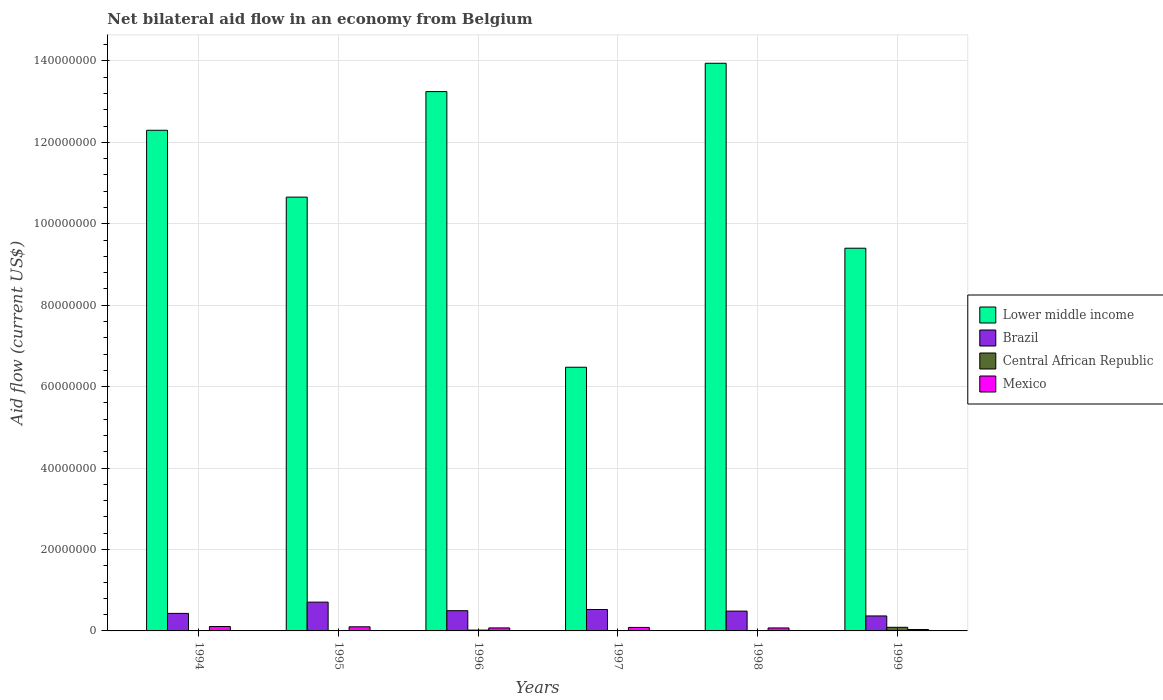How many different coloured bars are there?
Make the answer very short. 4. Are the number of bars on each tick of the X-axis equal?
Your answer should be very brief. Yes. How many bars are there on the 4th tick from the left?
Keep it short and to the point. 4. What is the net bilateral aid flow in Central African Republic in 1994?
Your response must be concise. 3.00e+04. Across all years, what is the maximum net bilateral aid flow in Mexico?
Ensure brevity in your answer.  1.08e+06. Across all years, what is the minimum net bilateral aid flow in Lower middle income?
Your answer should be compact. 6.48e+07. In which year was the net bilateral aid flow in Brazil minimum?
Offer a very short reply. 1999. What is the total net bilateral aid flow in Brazil in the graph?
Keep it short and to the point. 3.02e+07. What is the difference between the net bilateral aid flow in Lower middle income in 1994 and that in 1999?
Offer a terse response. 2.90e+07. What is the difference between the net bilateral aid flow in Central African Republic in 1998 and the net bilateral aid flow in Lower middle income in 1996?
Your answer should be very brief. -1.32e+08. What is the average net bilateral aid flow in Mexico per year?
Give a very brief answer. 7.95e+05. In the year 1996, what is the difference between the net bilateral aid flow in Brazil and net bilateral aid flow in Lower middle income?
Offer a very short reply. -1.28e+08. What is the ratio of the net bilateral aid flow in Lower middle income in 1994 to that in 1996?
Your answer should be very brief. 0.93. Is the difference between the net bilateral aid flow in Brazil in 1996 and 1999 greater than the difference between the net bilateral aid flow in Lower middle income in 1996 and 1999?
Provide a short and direct response. No. What is the difference between the highest and the second highest net bilateral aid flow in Central African Republic?
Your answer should be compact. 6.90e+05. What is the difference between the highest and the lowest net bilateral aid flow in Brazil?
Ensure brevity in your answer.  3.39e+06. Is the sum of the net bilateral aid flow in Mexico in 1995 and 1998 greater than the maximum net bilateral aid flow in Central African Republic across all years?
Keep it short and to the point. Yes. What does the 3rd bar from the left in 1998 represents?
Give a very brief answer. Central African Republic. What does the 1st bar from the right in 1996 represents?
Ensure brevity in your answer.  Mexico. Is it the case that in every year, the sum of the net bilateral aid flow in Brazil and net bilateral aid flow in Lower middle income is greater than the net bilateral aid flow in Central African Republic?
Make the answer very short. Yes. How many bars are there?
Provide a short and direct response. 24. How many years are there in the graph?
Provide a succinct answer. 6. What is the difference between two consecutive major ticks on the Y-axis?
Your answer should be very brief. 2.00e+07. Are the values on the major ticks of Y-axis written in scientific E-notation?
Your response must be concise. No. Does the graph contain any zero values?
Offer a terse response. No. Does the graph contain grids?
Keep it short and to the point. Yes. How are the legend labels stacked?
Your response must be concise. Vertical. What is the title of the graph?
Your answer should be very brief. Net bilateral aid flow in an economy from Belgium. Does "Portugal" appear as one of the legend labels in the graph?
Ensure brevity in your answer.  No. What is the label or title of the Y-axis?
Make the answer very short. Aid flow (current US$). What is the Aid flow (current US$) in Lower middle income in 1994?
Ensure brevity in your answer.  1.23e+08. What is the Aid flow (current US$) of Brazil in 1994?
Provide a short and direct response. 4.31e+06. What is the Aid flow (current US$) in Central African Republic in 1994?
Keep it short and to the point. 3.00e+04. What is the Aid flow (current US$) in Mexico in 1994?
Your answer should be compact. 1.08e+06. What is the Aid flow (current US$) in Lower middle income in 1995?
Give a very brief answer. 1.07e+08. What is the Aid flow (current US$) in Brazil in 1995?
Your answer should be very brief. 7.07e+06. What is the Aid flow (current US$) in Central African Republic in 1995?
Offer a very short reply. 4.00e+04. What is the Aid flow (current US$) in Mexico in 1995?
Keep it short and to the point. 1.01e+06. What is the Aid flow (current US$) of Lower middle income in 1996?
Ensure brevity in your answer.  1.32e+08. What is the Aid flow (current US$) in Brazil in 1996?
Keep it short and to the point. 4.97e+06. What is the Aid flow (current US$) of Mexico in 1996?
Provide a succinct answer. 7.40e+05. What is the Aid flow (current US$) of Lower middle income in 1997?
Your response must be concise. 6.48e+07. What is the Aid flow (current US$) in Brazil in 1997?
Your answer should be very brief. 5.26e+06. What is the Aid flow (current US$) in Mexico in 1997?
Your answer should be compact. 8.60e+05. What is the Aid flow (current US$) in Lower middle income in 1998?
Make the answer very short. 1.39e+08. What is the Aid flow (current US$) of Brazil in 1998?
Your answer should be very brief. 4.87e+06. What is the Aid flow (current US$) in Central African Republic in 1998?
Provide a succinct answer. 8.00e+04. What is the Aid flow (current US$) in Mexico in 1998?
Keep it short and to the point. 7.30e+05. What is the Aid flow (current US$) of Lower middle income in 1999?
Your answer should be compact. 9.40e+07. What is the Aid flow (current US$) of Brazil in 1999?
Provide a succinct answer. 3.68e+06. What is the Aid flow (current US$) in Central African Republic in 1999?
Provide a succinct answer. 8.90e+05. What is the Aid flow (current US$) in Mexico in 1999?
Your response must be concise. 3.50e+05. Across all years, what is the maximum Aid flow (current US$) of Lower middle income?
Provide a succinct answer. 1.39e+08. Across all years, what is the maximum Aid flow (current US$) of Brazil?
Your response must be concise. 7.07e+06. Across all years, what is the maximum Aid flow (current US$) in Central African Republic?
Your answer should be very brief. 8.90e+05. Across all years, what is the maximum Aid flow (current US$) of Mexico?
Provide a succinct answer. 1.08e+06. Across all years, what is the minimum Aid flow (current US$) of Lower middle income?
Ensure brevity in your answer.  6.48e+07. Across all years, what is the minimum Aid flow (current US$) of Brazil?
Keep it short and to the point. 3.68e+06. What is the total Aid flow (current US$) in Lower middle income in the graph?
Provide a short and direct response. 6.60e+08. What is the total Aid flow (current US$) in Brazil in the graph?
Keep it short and to the point. 3.02e+07. What is the total Aid flow (current US$) in Central African Republic in the graph?
Your answer should be compact. 1.31e+06. What is the total Aid flow (current US$) of Mexico in the graph?
Your answer should be very brief. 4.77e+06. What is the difference between the Aid flow (current US$) in Lower middle income in 1994 and that in 1995?
Ensure brevity in your answer.  1.64e+07. What is the difference between the Aid flow (current US$) in Brazil in 1994 and that in 1995?
Keep it short and to the point. -2.76e+06. What is the difference between the Aid flow (current US$) of Central African Republic in 1994 and that in 1995?
Make the answer very short. -10000. What is the difference between the Aid flow (current US$) in Mexico in 1994 and that in 1995?
Make the answer very short. 7.00e+04. What is the difference between the Aid flow (current US$) of Lower middle income in 1994 and that in 1996?
Offer a very short reply. -9.50e+06. What is the difference between the Aid flow (current US$) in Brazil in 1994 and that in 1996?
Provide a succinct answer. -6.60e+05. What is the difference between the Aid flow (current US$) in Central African Republic in 1994 and that in 1996?
Your answer should be compact. -1.70e+05. What is the difference between the Aid flow (current US$) of Mexico in 1994 and that in 1996?
Ensure brevity in your answer.  3.40e+05. What is the difference between the Aid flow (current US$) in Lower middle income in 1994 and that in 1997?
Your response must be concise. 5.82e+07. What is the difference between the Aid flow (current US$) of Brazil in 1994 and that in 1997?
Give a very brief answer. -9.50e+05. What is the difference between the Aid flow (current US$) of Lower middle income in 1994 and that in 1998?
Your response must be concise. -1.65e+07. What is the difference between the Aid flow (current US$) in Brazil in 1994 and that in 1998?
Provide a succinct answer. -5.60e+05. What is the difference between the Aid flow (current US$) of Mexico in 1994 and that in 1998?
Offer a terse response. 3.50e+05. What is the difference between the Aid flow (current US$) in Lower middle income in 1994 and that in 1999?
Make the answer very short. 2.90e+07. What is the difference between the Aid flow (current US$) of Brazil in 1994 and that in 1999?
Your answer should be very brief. 6.30e+05. What is the difference between the Aid flow (current US$) in Central African Republic in 1994 and that in 1999?
Your response must be concise. -8.60e+05. What is the difference between the Aid flow (current US$) of Mexico in 1994 and that in 1999?
Your answer should be compact. 7.30e+05. What is the difference between the Aid flow (current US$) in Lower middle income in 1995 and that in 1996?
Provide a short and direct response. -2.59e+07. What is the difference between the Aid flow (current US$) in Brazil in 1995 and that in 1996?
Give a very brief answer. 2.10e+06. What is the difference between the Aid flow (current US$) in Lower middle income in 1995 and that in 1997?
Offer a terse response. 4.18e+07. What is the difference between the Aid flow (current US$) in Brazil in 1995 and that in 1997?
Your answer should be very brief. 1.81e+06. What is the difference between the Aid flow (current US$) in Central African Republic in 1995 and that in 1997?
Offer a very short reply. -3.00e+04. What is the difference between the Aid flow (current US$) of Mexico in 1995 and that in 1997?
Provide a succinct answer. 1.50e+05. What is the difference between the Aid flow (current US$) of Lower middle income in 1995 and that in 1998?
Your answer should be very brief. -3.29e+07. What is the difference between the Aid flow (current US$) in Brazil in 1995 and that in 1998?
Your response must be concise. 2.20e+06. What is the difference between the Aid flow (current US$) of Lower middle income in 1995 and that in 1999?
Keep it short and to the point. 1.26e+07. What is the difference between the Aid flow (current US$) in Brazil in 1995 and that in 1999?
Ensure brevity in your answer.  3.39e+06. What is the difference between the Aid flow (current US$) in Central African Republic in 1995 and that in 1999?
Your answer should be compact. -8.50e+05. What is the difference between the Aid flow (current US$) in Lower middle income in 1996 and that in 1997?
Your response must be concise. 6.77e+07. What is the difference between the Aid flow (current US$) in Central African Republic in 1996 and that in 1997?
Provide a succinct answer. 1.30e+05. What is the difference between the Aid flow (current US$) of Mexico in 1996 and that in 1997?
Give a very brief answer. -1.20e+05. What is the difference between the Aid flow (current US$) of Lower middle income in 1996 and that in 1998?
Make the answer very short. -6.96e+06. What is the difference between the Aid flow (current US$) in Mexico in 1996 and that in 1998?
Make the answer very short. 10000. What is the difference between the Aid flow (current US$) in Lower middle income in 1996 and that in 1999?
Provide a short and direct response. 3.85e+07. What is the difference between the Aid flow (current US$) in Brazil in 1996 and that in 1999?
Ensure brevity in your answer.  1.29e+06. What is the difference between the Aid flow (current US$) in Central African Republic in 1996 and that in 1999?
Your answer should be compact. -6.90e+05. What is the difference between the Aid flow (current US$) in Lower middle income in 1997 and that in 1998?
Offer a very short reply. -7.47e+07. What is the difference between the Aid flow (current US$) in Central African Republic in 1997 and that in 1998?
Your response must be concise. -10000. What is the difference between the Aid flow (current US$) of Lower middle income in 1997 and that in 1999?
Provide a succinct answer. -2.92e+07. What is the difference between the Aid flow (current US$) in Brazil in 1997 and that in 1999?
Offer a terse response. 1.58e+06. What is the difference between the Aid flow (current US$) in Central African Republic in 1997 and that in 1999?
Offer a terse response. -8.20e+05. What is the difference between the Aid flow (current US$) in Mexico in 1997 and that in 1999?
Your answer should be very brief. 5.10e+05. What is the difference between the Aid flow (current US$) in Lower middle income in 1998 and that in 1999?
Give a very brief answer. 4.54e+07. What is the difference between the Aid flow (current US$) in Brazil in 1998 and that in 1999?
Your response must be concise. 1.19e+06. What is the difference between the Aid flow (current US$) in Central African Republic in 1998 and that in 1999?
Offer a terse response. -8.10e+05. What is the difference between the Aid flow (current US$) of Lower middle income in 1994 and the Aid flow (current US$) of Brazil in 1995?
Ensure brevity in your answer.  1.16e+08. What is the difference between the Aid flow (current US$) of Lower middle income in 1994 and the Aid flow (current US$) of Central African Republic in 1995?
Your response must be concise. 1.23e+08. What is the difference between the Aid flow (current US$) of Lower middle income in 1994 and the Aid flow (current US$) of Mexico in 1995?
Offer a very short reply. 1.22e+08. What is the difference between the Aid flow (current US$) in Brazil in 1994 and the Aid flow (current US$) in Central African Republic in 1995?
Provide a short and direct response. 4.27e+06. What is the difference between the Aid flow (current US$) in Brazil in 1994 and the Aid flow (current US$) in Mexico in 1995?
Your answer should be compact. 3.30e+06. What is the difference between the Aid flow (current US$) in Central African Republic in 1994 and the Aid flow (current US$) in Mexico in 1995?
Your answer should be very brief. -9.80e+05. What is the difference between the Aid flow (current US$) in Lower middle income in 1994 and the Aid flow (current US$) in Brazil in 1996?
Offer a terse response. 1.18e+08. What is the difference between the Aid flow (current US$) of Lower middle income in 1994 and the Aid flow (current US$) of Central African Republic in 1996?
Offer a very short reply. 1.23e+08. What is the difference between the Aid flow (current US$) of Lower middle income in 1994 and the Aid flow (current US$) of Mexico in 1996?
Give a very brief answer. 1.22e+08. What is the difference between the Aid flow (current US$) in Brazil in 1994 and the Aid flow (current US$) in Central African Republic in 1996?
Keep it short and to the point. 4.11e+06. What is the difference between the Aid flow (current US$) of Brazil in 1994 and the Aid flow (current US$) of Mexico in 1996?
Offer a very short reply. 3.57e+06. What is the difference between the Aid flow (current US$) of Central African Republic in 1994 and the Aid flow (current US$) of Mexico in 1996?
Keep it short and to the point. -7.10e+05. What is the difference between the Aid flow (current US$) in Lower middle income in 1994 and the Aid flow (current US$) in Brazil in 1997?
Provide a succinct answer. 1.18e+08. What is the difference between the Aid flow (current US$) in Lower middle income in 1994 and the Aid flow (current US$) in Central African Republic in 1997?
Provide a short and direct response. 1.23e+08. What is the difference between the Aid flow (current US$) of Lower middle income in 1994 and the Aid flow (current US$) of Mexico in 1997?
Ensure brevity in your answer.  1.22e+08. What is the difference between the Aid flow (current US$) in Brazil in 1994 and the Aid flow (current US$) in Central African Republic in 1997?
Your answer should be very brief. 4.24e+06. What is the difference between the Aid flow (current US$) of Brazil in 1994 and the Aid flow (current US$) of Mexico in 1997?
Provide a short and direct response. 3.45e+06. What is the difference between the Aid flow (current US$) of Central African Republic in 1994 and the Aid flow (current US$) of Mexico in 1997?
Make the answer very short. -8.30e+05. What is the difference between the Aid flow (current US$) in Lower middle income in 1994 and the Aid flow (current US$) in Brazil in 1998?
Make the answer very short. 1.18e+08. What is the difference between the Aid flow (current US$) in Lower middle income in 1994 and the Aid flow (current US$) in Central African Republic in 1998?
Your answer should be compact. 1.23e+08. What is the difference between the Aid flow (current US$) in Lower middle income in 1994 and the Aid flow (current US$) in Mexico in 1998?
Offer a very short reply. 1.22e+08. What is the difference between the Aid flow (current US$) of Brazil in 1994 and the Aid flow (current US$) of Central African Republic in 1998?
Give a very brief answer. 4.23e+06. What is the difference between the Aid flow (current US$) in Brazil in 1994 and the Aid flow (current US$) in Mexico in 1998?
Offer a terse response. 3.58e+06. What is the difference between the Aid flow (current US$) in Central African Republic in 1994 and the Aid flow (current US$) in Mexico in 1998?
Provide a short and direct response. -7.00e+05. What is the difference between the Aid flow (current US$) of Lower middle income in 1994 and the Aid flow (current US$) of Brazil in 1999?
Your answer should be compact. 1.19e+08. What is the difference between the Aid flow (current US$) of Lower middle income in 1994 and the Aid flow (current US$) of Central African Republic in 1999?
Offer a very short reply. 1.22e+08. What is the difference between the Aid flow (current US$) in Lower middle income in 1994 and the Aid flow (current US$) in Mexico in 1999?
Provide a succinct answer. 1.23e+08. What is the difference between the Aid flow (current US$) of Brazil in 1994 and the Aid flow (current US$) of Central African Republic in 1999?
Give a very brief answer. 3.42e+06. What is the difference between the Aid flow (current US$) of Brazil in 1994 and the Aid flow (current US$) of Mexico in 1999?
Provide a succinct answer. 3.96e+06. What is the difference between the Aid flow (current US$) of Central African Republic in 1994 and the Aid flow (current US$) of Mexico in 1999?
Make the answer very short. -3.20e+05. What is the difference between the Aid flow (current US$) in Lower middle income in 1995 and the Aid flow (current US$) in Brazil in 1996?
Make the answer very short. 1.02e+08. What is the difference between the Aid flow (current US$) in Lower middle income in 1995 and the Aid flow (current US$) in Central African Republic in 1996?
Your answer should be very brief. 1.06e+08. What is the difference between the Aid flow (current US$) of Lower middle income in 1995 and the Aid flow (current US$) of Mexico in 1996?
Ensure brevity in your answer.  1.06e+08. What is the difference between the Aid flow (current US$) of Brazil in 1995 and the Aid flow (current US$) of Central African Republic in 1996?
Provide a succinct answer. 6.87e+06. What is the difference between the Aid flow (current US$) of Brazil in 1995 and the Aid flow (current US$) of Mexico in 1996?
Ensure brevity in your answer.  6.33e+06. What is the difference between the Aid flow (current US$) in Central African Republic in 1995 and the Aid flow (current US$) in Mexico in 1996?
Ensure brevity in your answer.  -7.00e+05. What is the difference between the Aid flow (current US$) of Lower middle income in 1995 and the Aid flow (current US$) of Brazil in 1997?
Provide a short and direct response. 1.01e+08. What is the difference between the Aid flow (current US$) in Lower middle income in 1995 and the Aid flow (current US$) in Central African Republic in 1997?
Keep it short and to the point. 1.06e+08. What is the difference between the Aid flow (current US$) in Lower middle income in 1995 and the Aid flow (current US$) in Mexico in 1997?
Provide a short and direct response. 1.06e+08. What is the difference between the Aid flow (current US$) in Brazil in 1995 and the Aid flow (current US$) in Mexico in 1997?
Provide a succinct answer. 6.21e+06. What is the difference between the Aid flow (current US$) in Central African Republic in 1995 and the Aid flow (current US$) in Mexico in 1997?
Offer a terse response. -8.20e+05. What is the difference between the Aid flow (current US$) of Lower middle income in 1995 and the Aid flow (current US$) of Brazil in 1998?
Offer a very short reply. 1.02e+08. What is the difference between the Aid flow (current US$) in Lower middle income in 1995 and the Aid flow (current US$) in Central African Republic in 1998?
Ensure brevity in your answer.  1.06e+08. What is the difference between the Aid flow (current US$) of Lower middle income in 1995 and the Aid flow (current US$) of Mexico in 1998?
Ensure brevity in your answer.  1.06e+08. What is the difference between the Aid flow (current US$) of Brazil in 1995 and the Aid flow (current US$) of Central African Republic in 1998?
Make the answer very short. 6.99e+06. What is the difference between the Aid flow (current US$) in Brazil in 1995 and the Aid flow (current US$) in Mexico in 1998?
Keep it short and to the point. 6.34e+06. What is the difference between the Aid flow (current US$) in Central African Republic in 1995 and the Aid flow (current US$) in Mexico in 1998?
Ensure brevity in your answer.  -6.90e+05. What is the difference between the Aid flow (current US$) in Lower middle income in 1995 and the Aid flow (current US$) in Brazil in 1999?
Make the answer very short. 1.03e+08. What is the difference between the Aid flow (current US$) in Lower middle income in 1995 and the Aid flow (current US$) in Central African Republic in 1999?
Your answer should be compact. 1.06e+08. What is the difference between the Aid flow (current US$) in Lower middle income in 1995 and the Aid flow (current US$) in Mexico in 1999?
Your answer should be very brief. 1.06e+08. What is the difference between the Aid flow (current US$) in Brazil in 1995 and the Aid flow (current US$) in Central African Republic in 1999?
Make the answer very short. 6.18e+06. What is the difference between the Aid flow (current US$) of Brazil in 1995 and the Aid flow (current US$) of Mexico in 1999?
Provide a succinct answer. 6.72e+06. What is the difference between the Aid flow (current US$) of Central African Republic in 1995 and the Aid flow (current US$) of Mexico in 1999?
Keep it short and to the point. -3.10e+05. What is the difference between the Aid flow (current US$) in Lower middle income in 1996 and the Aid flow (current US$) in Brazil in 1997?
Make the answer very short. 1.27e+08. What is the difference between the Aid flow (current US$) in Lower middle income in 1996 and the Aid flow (current US$) in Central African Republic in 1997?
Keep it short and to the point. 1.32e+08. What is the difference between the Aid flow (current US$) in Lower middle income in 1996 and the Aid flow (current US$) in Mexico in 1997?
Ensure brevity in your answer.  1.32e+08. What is the difference between the Aid flow (current US$) in Brazil in 1996 and the Aid flow (current US$) in Central African Republic in 1997?
Offer a terse response. 4.90e+06. What is the difference between the Aid flow (current US$) of Brazil in 1996 and the Aid flow (current US$) of Mexico in 1997?
Ensure brevity in your answer.  4.11e+06. What is the difference between the Aid flow (current US$) in Central African Republic in 1996 and the Aid flow (current US$) in Mexico in 1997?
Make the answer very short. -6.60e+05. What is the difference between the Aid flow (current US$) of Lower middle income in 1996 and the Aid flow (current US$) of Brazil in 1998?
Your answer should be very brief. 1.28e+08. What is the difference between the Aid flow (current US$) in Lower middle income in 1996 and the Aid flow (current US$) in Central African Republic in 1998?
Provide a succinct answer. 1.32e+08. What is the difference between the Aid flow (current US$) of Lower middle income in 1996 and the Aid flow (current US$) of Mexico in 1998?
Give a very brief answer. 1.32e+08. What is the difference between the Aid flow (current US$) in Brazil in 1996 and the Aid flow (current US$) in Central African Republic in 1998?
Ensure brevity in your answer.  4.89e+06. What is the difference between the Aid flow (current US$) of Brazil in 1996 and the Aid flow (current US$) of Mexico in 1998?
Provide a succinct answer. 4.24e+06. What is the difference between the Aid flow (current US$) of Central African Republic in 1996 and the Aid flow (current US$) of Mexico in 1998?
Make the answer very short. -5.30e+05. What is the difference between the Aid flow (current US$) in Lower middle income in 1996 and the Aid flow (current US$) in Brazil in 1999?
Offer a terse response. 1.29e+08. What is the difference between the Aid flow (current US$) in Lower middle income in 1996 and the Aid flow (current US$) in Central African Republic in 1999?
Offer a terse response. 1.32e+08. What is the difference between the Aid flow (current US$) of Lower middle income in 1996 and the Aid flow (current US$) of Mexico in 1999?
Offer a terse response. 1.32e+08. What is the difference between the Aid flow (current US$) in Brazil in 1996 and the Aid flow (current US$) in Central African Republic in 1999?
Keep it short and to the point. 4.08e+06. What is the difference between the Aid flow (current US$) in Brazil in 1996 and the Aid flow (current US$) in Mexico in 1999?
Your answer should be compact. 4.62e+06. What is the difference between the Aid flow (current US$) in Central African Republic in 1996 and the Aid flow (current US$) in Mexico in 1999?
Offer a very short reply. -1.50e+05. What is the difference between the Aid flow (current US$) in Lower middle income in 1997 and the Aid flow (current US$) in Brazil in 1998?
Make the answer very short. 5.99e+07. What is the difference between the Aid flow (current US$) of Lower middle income in 1997 and the Aid flow (current US$) of Central African Republic in 1998?
Your answer should be very brief. 6.47e+07. What is the difference between the Aid flow (current US$) of Lower middle income in 1997 and the Aid flow (current US$) of Mexico in 1998?
Your response must be concise. 6.40e+07. What is the difference between the Aid flow (current US$) of Brazil in 1997 and the Aid flow (current US$) of Central African Republic in 1998?
Make the answer very short. 5.18e+06. What is the difference between the Aid flow (current US$) of Brazil in 1997 and the Aid flow (current US$) of Mexico in 1998?
Give a very brief answer. 4.53e+06. What is the difference between the Aid flow (current US$) of Central African Republic in 1997 and the Aid flow (current US$) of Mexico in 1998?
Make the answer very short. -6.60e+05. What is the difference between the Aid flow (current US$) of Lower middle income in 1997 and the Aid flow (current US$) of Brazil in 1999?
Provide a short and direct response. 6.11e+07. What is the difference between the Aid flow (current US$) of Lower middle income in 1997 and the Aid flow (current US$) of Central African Republic in 1999?
Provide a succinct answer. 6.39e+07. What is the difference between the Aid flow (current US$) in Lower middle income in 1997 and the Aid flow (current US$) in Mexico in 1999?
Keep it short and to the point. 6.44e+07. What is the difference between the Aid flow (current US$) in Brazil in 1997 and the Aid flow (current US$) in Central African Republic in 1999?
Provide a short and direct response. 4.37e+06. What is the difference between the Aid flow (current US$) of Brazil in 1997 and the Aid flow (current US$) of Mexico in 1999?
Your answer should be very brief. 4.91e+06. What is the difference between the Aid flow (current US$) of Central African Republic in 1997 and the Aid flow (current US$) of Mexico in 1999?
Give a very brief answer. -2.80e+05. What is the difference between the Aid flow (current US$) in Lower middle income in 1998 and the Aid flow (current US$) in Brazil in 1999?
Make the answer very short. 1.36e+08. What is the difference between the Aid flow (current US$) in Lower middle income in 1998 and the Aid flow (current US$) in Central African Republic in 1999?
Make the answer very short. 1.39e+08. What is the difference between the Aid flow (current US$) of Lower middle income in 1998 and the Aid flow (current US$) of Mexico in 1999?
Give a very brief answer. 1.39e+08. What is the difference between the Aid flow (current US$) of Brazil in 1998 and the Aid flow (current US$) of Central African Republic in 1999?
Make the answer very short. 3.98e+06. What is the difference between the Aid flow (current US$) of Brazil in 1998 and the Aid flow (current US$) of Mexico in 1999?
Provide a short and direct response. 4.52e+06. What is the difference between the Aid flow (current US$) in Central African Republic in 1998 and the Aid flow (current US$) in Mexico in 1999?
Give a very brief answer. -2.70e+05. What is the average Aid flow (current US$) of Lower middle income per year?
Your response must be concise. 1.10e+08. What is the average Aid flow (current US$) in Brazil per year?
Your response must be concise. 5.03e+06. What is the average Aid flow (current US$) in Central African Republic per year?
Your answer should be very brief. 2.18e+05. What is the average Aid flow (current US$) of Mexico per year?
Provide a succinct answer. 7.95e+05. In the year 1994, what is the difference between the Aid flow (current US$) in Lower middle income and Aid flow (current US$) in Brazil?
Provide a short and direct response. 1.19e+08. In the year 1994, what is the difference between the Aid flow (current US$) in Lower middle income and Aid flow (current US$) in Central African Republic?
Offer a very short reply. 1.23e+08. In the year 1994, what is the difference between the Aid flow (current US$) in Lower middle income and Aid flow (current US$) in Mexico?
Your response must be concise. 1.22e+08. In the year 1994, what is the difference between the Aid flow (current US$) of Brazil and Aid flow (current US$) of Central African Republic?
Offer a terse response. 4.28e+06. In the year 1994, what is the difference between the Aid flow (current US$) of Brazil and Aid flow (current US$) of Mexico?
Your answer should be compact. 3.23e+06. In the year 1994, what is the difference between the Aid flow (current US$) of Central African Republic and Aid flow (current US$) of Mexico?
Your answer should be compact. -1.05e+06. In the year 1995, what is the difference between the Aid flow (current US$) in Lower middle income and Aid flow (current US$) in Brazil?
Keep it short and to the point. 9.95e+07. In the year 1995, what is the difference between the Aid flow (current US$) of Lower middle income and Aid flow (current US$) of Central African Republic?
Your answer should be very brief. 1.07e+08. In the year 1995, what is the difference between the Aid flow (current US$) of Lower middle income and Aid flow (current US$) of Mexico?
Your answer should be compact. 1.06e+08. In the year 1995, what is the difference between the Aid flow (current US$) of Brazil and Aid flow (current US$) of Central African Republic?
Ensure brevity in your answer.  7.03e+06. In the year 1995, what is the difference between the Aid flow (current US$) in Brazil and Aid flow (current US$) in Mexico?
Provide a short and direct response. 6.06e+06. In the year 1995, what is the difference between the Aid flow (current US$) in Central African Republic and Aid flow (current US$) in Mexico?
Your answer should be compact. -9.70e+05. In the year 1996, what is the difference between the Aid flow (current US$) in Lower middle income and Aid flow (current US$) in Brazil?
Offer a terse response. 1.28e+08. In the year 1996, what is the difference between the Aid flow (current US$) of Lower middle income and Aid flow (current US$) of Central African Republic?
Ensure brevity in your answer.  1.32e+08. In the year 1996, what is the difference between the Aid flow (current US$) in Lower middle income and Aid flow (current US$) in Mexico?
Provide a short and direct response. 1.32e+08. In the year 1996, what is the difference between the Aid flow (current US$) of Brazil and Aid flow (current US$) of Central African Republic?
Your response must be concise. 4.77e+06. In the year 1996, what is the difference between the Aid flow (current US$) of Brazil and Aid flow (current US$) of Mexico?
Provide a succinct answer. 4.23e+06. In the year 1996, what is the difference between the Aid flow (current US$) of Central African Republic and Aid flow (current US$) of Mexico?
Your answer should be very brief. -5.40e+05. In the year 1997, what is the difference between the Aid flow (current US$) in Lower middle income and Aid flow (current US$) in Brazil?
Offer a very short reply. 5.95e+07. In the year 1997, what is the difference between the Aid flow (current US$) of Lower middle income and Aid flow (current US$) of Central African Republic?
Your answer should be very brief. 6.47e+07. In the year 1997, what is the difference between the Aid flow (current US$) of Lower middle income and Aid flow (current US$) of Mexico?
Make the answer very short. 6.39e+07. In the year 1997, what is the difference between the Aid flow (current US$) in Brazil and Aid flow (current US$) in Central African Republic?
Keep it short and to the point. 5.19e+06. In the year 1997, what is the difference between the Aid flow (current US$) in Brazil and Aid flow (current US$) in Mexico?
Your response must be concise. 4.40e+06. In the year 1997, what is the difference between the Aid flow (current US$) of Central African Republic and Aid flow (current US$) of Mexico?
Keep it short and to the point. -7.90e+05. In the year 1998, what is the difference between the Aid flow (current US$) in Lower middle income and Aid flow (current US$) in Brazil?
Ensure brevity in your answer.  1.35e+08. In the year 1998, what is the difference between the Aid flow (current US$) in Lower middle income and Aid flow (current US$) in Central African Republic?
Offer a very short reply. 1.39e+08. In the year 1998, what is the difference between the Aid flow (current US$) of Lower middle income and Aid flow (current US$) of Mexico?
Keep it short and to the point. 1.39e+08. In the year 1998, what is the difference between the Aid flow (current US$) of Brazil and Aid flow (current US$) of Central African Republic?
Your answer should be very brief. 4.79e+06. In the year 1998, what is the difference between the Aid flow (current US$) of Brazil and Aid flow (current US$) of Mexico?
Make the answer very short. 4.14e+06. In the year 1998, what is the difference between the Aid flow (current US$) in Central African Republic and Aid flow (current US$) in Mexico?
Your response must be concise. -6.50e+05. In the year 1999, what is the difference between the Aid flow (current US$) in Lower middle income and Aid flow (current US$) in Brazil?
Ensure brevity in your answer.  9.03e+07. In the year 1999, what is the difference between the Aid flow (current US$) of Lower middle income and Aid flow (current US$) of Central African Republic?
Your response must be concise. 9.31e+07. In the year 1999, what is the difference between the Aid flow (current US$) of Lower middle income and Aid flow (current US$) of Mexico?
Offer a terse response. 9.37e+07. In the year 1999, what is the difference between the Aid flow (current US$) in Brazil and Aid flow (current US$) in Central African Republic?
Ensure brevity in your answer.  2.79e+06. In the year 1999, what is the difference between the Aid flow (current US$) in Brazil and Aid flow (current US$) in Mexico?
Your answer should be compact. 3.33e+06. In the year 1999, what is the difference between the Aid flow (current US$) of Central African Republic and Aid flow (current US$) of Mexico?
Provide a short and direct response. 5.40e+05. What is the ratio of the Aid flow (current US$) in Lower middle income in 1994 to that in 1995?
Provide a succinct answer. 1.15. What is the ratio of the Aid flow (current US$) of Brazil in 1994 to that in 1995?
Provide a short and direct response. 0.61. What is the ratio of the Aid flow (current US$) in Mexico in 1994 to that in 1995?
Provide a succinct answer. 1.07. What is the ratio of the Aid flow (current US$) in Lower middle income in 1994 to that in 1996?
Your response must be concise. 0.93. What is the ratio of the Aid flow (current US$) of Brazil in 1994 to that in 1996?
Offer a terse response. 0.87. What is the ratio of the Aid flow (current US$) in Central African Republic in 1994 to that in 1996?
Ensure brevity in your answer.  0.15. What is the ratio of the Aid flow (current US$) in Mexico in 1994 to that in 1996?
Provide a succinct answer. 1.46. What is the ratio of the Aid flow (current US$) of Lower middle income in 1994 to that in 1997?
Ensure brevity in your answer.  1.9. What is the ratio of the Aid flow (current US$) in Brazil in 1994 to that in 1997?
Your answer should be very brief. 0.82. What is the ratio of the Aid flow (current US$) in Central African Republic in 1994 to that in 1997?
Offer a terse response. 0.43. What is the ratio of the Aid flow (current US$) in Mexico in 1994 to that in 1997?
Give a very brief answer. 1.26. What is the ratio of the Aid flow (current US$) in Lower middle income in 1994 to that in 1998?
Ensure brevity in your answer.  0.88. What is the ratio of the Aid flow (current US$) in Brazil in 1994 to that in 1998?
Offer a terse response. 0.89. What is the ratio of the Aid flow (current US$) of Central African Republic in 1994 to that in 1998?
Your response must be concise. 0.38. What is the ratio of the Aid flow (current US$) in Mexico in 1994 to that in 1998?
Your answer should be very brief. 1.48. What is the ratio of the Aid flow (current US$) in Lower middle income in 1994 to that in 1999?
Ensure brevity in your answer.  1.31. What is the ratio of the Aid flow (current US$) in Brazil in 1994 to that in 1999?
Give a very brief answer. 1.17. What is the ratio of the Aid flow (current US$) of Central African Republic in 1994 to that in 1999?
Provide a succinct answer. 0.03. What is the ratio of the Aid flow (current US$) of Mexico in 1994 to that in 1999?
Offer a very short reply. 3.09. What is the ratio of the Aid flow (current US$) of Lower middle income in 1995 to that in 1996?
Offer a very short reply. 0.8. What is the ratio of the Aid flow (current US$) of Brazil in 1995 to that in 1996?
Offer a terse response. 1.42. What is the ratio of the Aid flow (current US$) in Central African Republic in 1995 to that in 1996?
Your answer should be very brief. 0.2. What is the ratio of the Aid flow (current US$) of Mexico in 1995 to that in 1996?
Make the answer very short. 1.36. What is the ratio of the Aid flow (current US$) in Lower middle income in 1995 to that in 1997?
Your answer should be compact. 1.65. What is the ratio of the Aid flow (current US$) of Brazil in 1995 to that in 1997?
Your response must be concise. 1.34. What is the ratio of the Aid flow (current US$) in Mexico in 1995 to that in 1997?
Provide a short and direct response. 1.17. What is the ratio of the Aid flow (current US$) in Lower middle income in 1995 to that in 1998?
Make the answer very short. 0.76. What is the ratio of the Aid flow (current US$) of Brazil in 1995 to that in 1998?
Offer a terse response. 1.45. What is the ratio of the Aid flow (current US$) in Central African Republic in 1995 to that in 1998?
Ensure brevity in your answer.  0.5. What is the ratio of the Aid flow (current US$) of Mexico in 1995 to that in 1998?
Your answer should be compact. 1.38. What is the ratio of the Aid flow (current US$) in Lower middle income in 1995 to that in 1999?
Make the answer very short. 1.13. What is the ratio of the Aid flow (current US$) in Brazil in 1995 to that in 1999?
Your answer should be very brief. 1.92. What is the ratio of the Aid flow (current US$) in Central African Republic in 1995 to that in 1999?
Ensure brevity in your answer.  0.04. What is the ratio of the Aid flow (current US$) of Mexico in 1995 to that in 1999?
Your answer should be compact. 2.89. What is the ratio of the Aid flow (current US$) in Lower middle income in 1996 to that in 1997?
Your response must be concise. 2.05. What is the ratio of the Aid flow (current US$) of Brazil in 1996 to that in 1997?
Ensure brevity in your answer.  0.94. What is the ratio of the Aid flow (current US$) of Central African Republic in 1996 to that in 1997?
Provide a succinct answer. 2.86. What is the ratio of the Aid flow (current US$) of Mexico in 1996 to that in 1997?
Provide a short and direct response. 0.86. What is the ratio of the Aid flow (current US$) in Lower middle income in 1996 to that in 1998?
Keep it short and to the point. 0.95. What is the ratio of the Aid flow (current US$) of Brazil in 1996 to that in 1998?
Your answer should be compact. 1.02. What is the ratio of the Aid flow (current US$) of Mexico in 1996 to that in 1998?
Give a very brief answer. 1.01. What is the ratio of the Aid flow (current US$) in Lower middle income in 1996 to that in 1999?
Give a very brief answer. 1.41. What is the ratio of the Aid flow (current US$) of Brazil in 1996 to that in 1999?
Your answer should be compact. 1.35. What is the ratio of the Aid flow (current US$) of Central African Republic in 1996 to that in 1999?
Offer a terse response. 0.22. What is the ratio of the Aid flow (current US$) in Mexico in 1996 to that in 1999?
Give a very brief answer. 2.11. What is the ratio of the Aid flow (current US$) of Lower middle income in 1997 to that in 1998?
Ensure brevity in your answer.  0.46. What is the ratio of the Aid flow (current US$) in Brazil in 1997 to that in 1998?
Provide a succinct answer. 1.08. What is the ratio of the Aid flow (current US$) of Central African Republic in 1997 to that in 1998?
Offer a terse response. 0.88. What is the ratio of the Aid flow (current US$) in Mexico in 1997 to that in 1998?
Your answer should be compact. 1.18. What is the ratio of the Aid flow (current US$) in Lower middle income in 1997 to that in 1999?
Offer a terse response. 0.69. What is the ratio of the Aid flow (current US$) of Brazil in 1997 to that in 1999?
Your response must be concise. 1.43. What is the ratio of the Aid flow (current US$) of Central African Republic in 1997 to that in 1999?
Offer a terse response. 0.08. What is the ratio of the Aid flow (current US$) in Mexico in 1997 to that in 1999?
Your answer should be compact. 2.46. What is the ratio of the Aid flow (current US$) of Lower middle income in 1998 to that in 1999?
Provide a succinct answer. 1.48. What is the ratio of the Aid flow (current US$) in Brazil in 1998 to that in 1999?
Offer a terse response. 1.32. What is the ratio of the Aid flow (current US$) of Central African Republic in 1998 to that in 1999?
Your answer should be compact. 0.09. What is the ratio of the Aid flow (current US$) of Mexico in 1998 to that in 1999?
Make the answer very short. 2.09. What is the difference between the highest and the second highest Aid flow (current US$) in Lower middle income?
Ensure brevity in your answer.  6.96e+06. What is the difference between the highest and the second highest Aid flow (current US$) of Brazil?
Keep it short and to the point. 1.81e+06. What is the difference between the highest and the second highest Aid flow (current US$) in Central African Republic?
Your answer should be compact. 6.90e+05. What is the difference between the highest and the lowest Aid flow (current US$) of Lower middle income?
Offer a terse response. 7.47e+07. What is the difference between the highest and the lowest Aid flow (current US$) in Brazil?
Your answer should be very brief. 3.39e+06. What is the difference between the highest and the lowest Aid flow (current US$) of Central African Republic?
Make the answer very short. 8.60e+05. What is the difference between the highest and the lowest Aid flow (current US$) in Mexico?
Ensure brevity in your answer.  7.30e+05. 